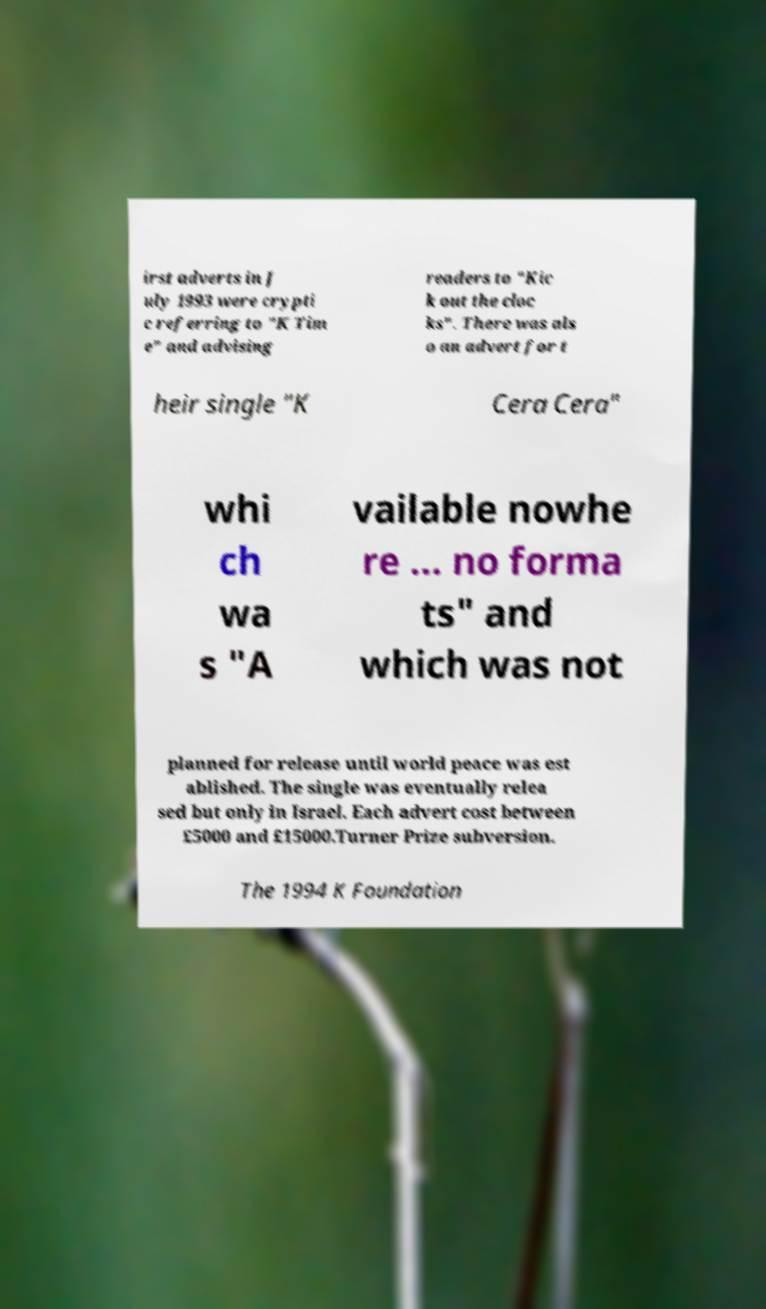For documentation purposes, I need the text within this image transcribed. Could you provide that? irst adverts in J uly 1993 were crypti c referring to "K Tim e" and advising readers to "Kic k out the cloc ks". There was als o an advert for t heir single "K Cera Cera" whi ch wa s "A vailable nowhe re ... no forma ts" and which was not planned for release until world peace was est ablished. The single was eventually relea sed but only in Israel. Each advert cost between £5000 and £15000.Turner Prize subversion. The 1994 K Foundation 